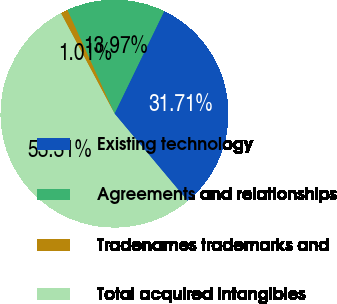<chart> <loc_0><loc_0><loc_500><loc_500><pie_chart><fcel>Existing technology<fcel>Agreements and relationships<fcel>Tradenames trademarks and<fcel>Total acquired intangibles<nl><fcel>31.71%<fcel>13.97%<fcel>1.01%<fcel>53.31%<nl></chart> 